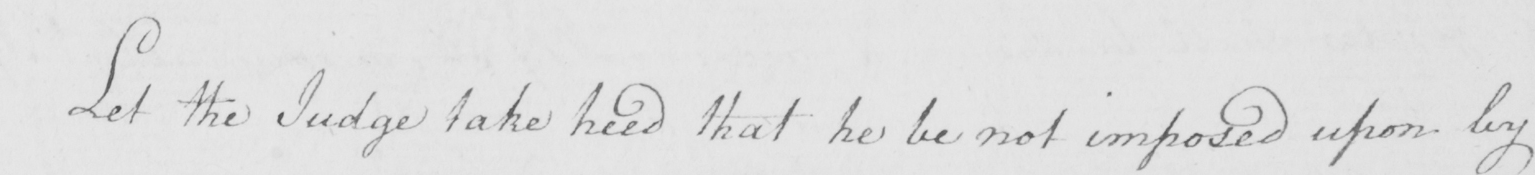What is written in this line of handwriting? Let the Judge take heed that he be not imposed upon by 